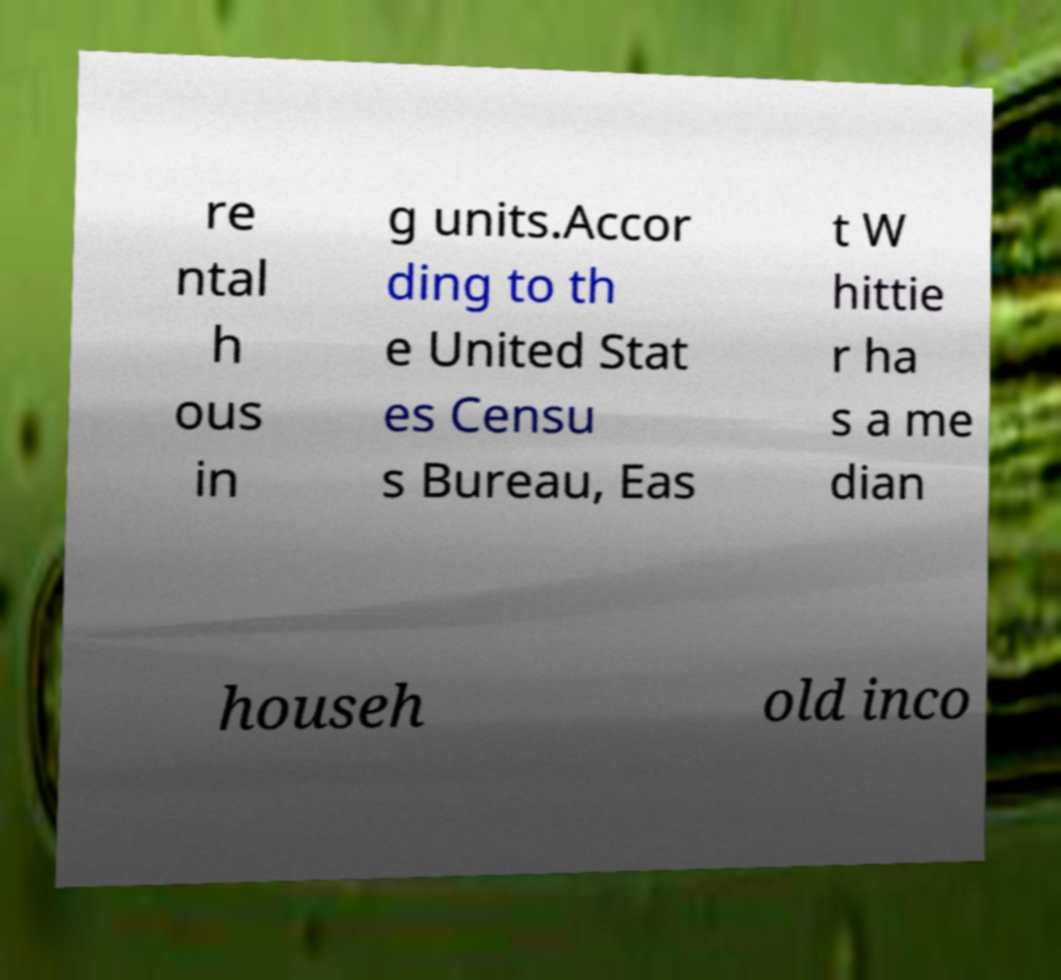Can you read and provide the text displayed in the image?This photo seems to have some interesting text. Can you extract and type it out for me? re ntal h ous in g units.Accor ding to th e United Stat es Censu s Bureau, Eas t W hittie r ha s a me dian househ old inco 